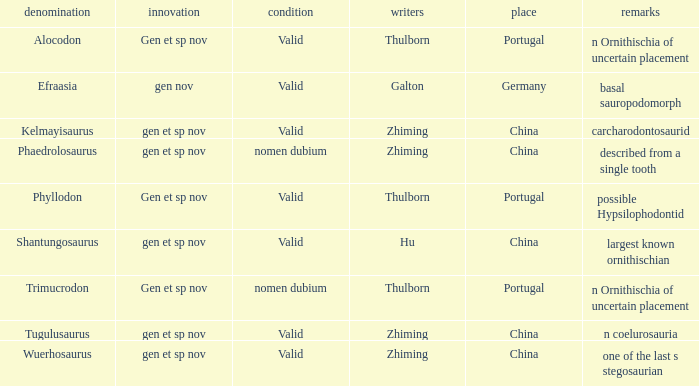What is the Status of the dinosaur, whose notes are, "n coelurosauria"? Valid. 